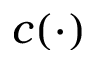<formula> <loc_0><loc_0><loc_500><loc_500>c ( \cdot )</formula> 